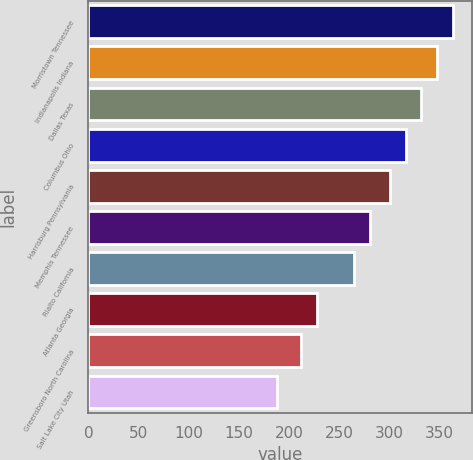<chart> <loc_0><loc_0><loc_500><loc_500><bar_chart><fcel>Morristown Tennessee<fcel>Indianapolis Indiana<fcel>Dallas Texas<fcel>Columbus Ohio<fcel>Harrisburg Pennsylvania<fcel>Memphis Tennessee<fcel>Rialto California<fcel>Atlanta Georgia<fcel>Greensboro North Carolina<fcel>Salt Lake City Utah<nl><fcel>363.6<fcel>347.7<fcel>331.8<fcel>315.9<fcel>300<fcel>280.9<fcel>265<fcel>227.9<fcel>212<fcel>188<nl></chart> 